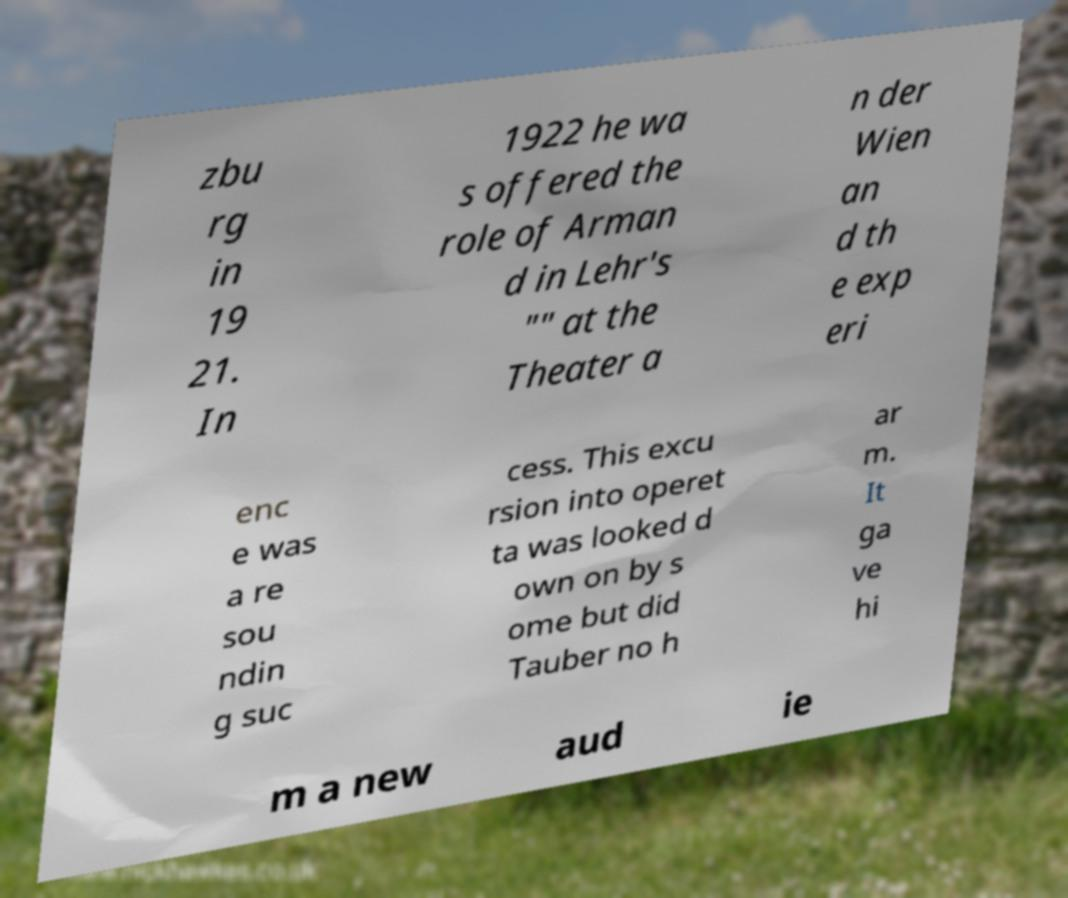There's text embedded in this image that I need extracted. Can you transcribe it verbatim? zbu rg in 19 21. In 1922 he wa s offered the role of Arman d in Lehr's "" at the Theater a n der Wien an d th e exp eri enc e was a re sou ndin g suc cess. This excu rsion into operet ta was looked d own on by s ome but did Tauber no h ar m. It ga ve hi m a new aud ie 